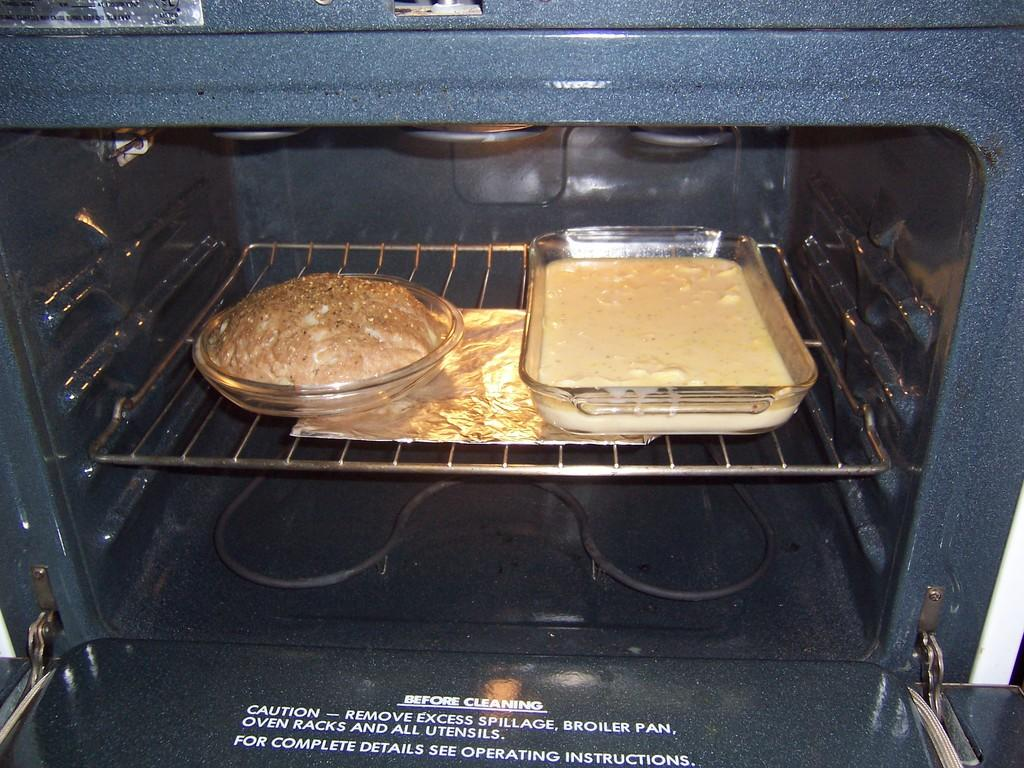<image>
Give a short and clear explanation of the subsequent image. An oven door gives instructions on what to do before cleaning. 